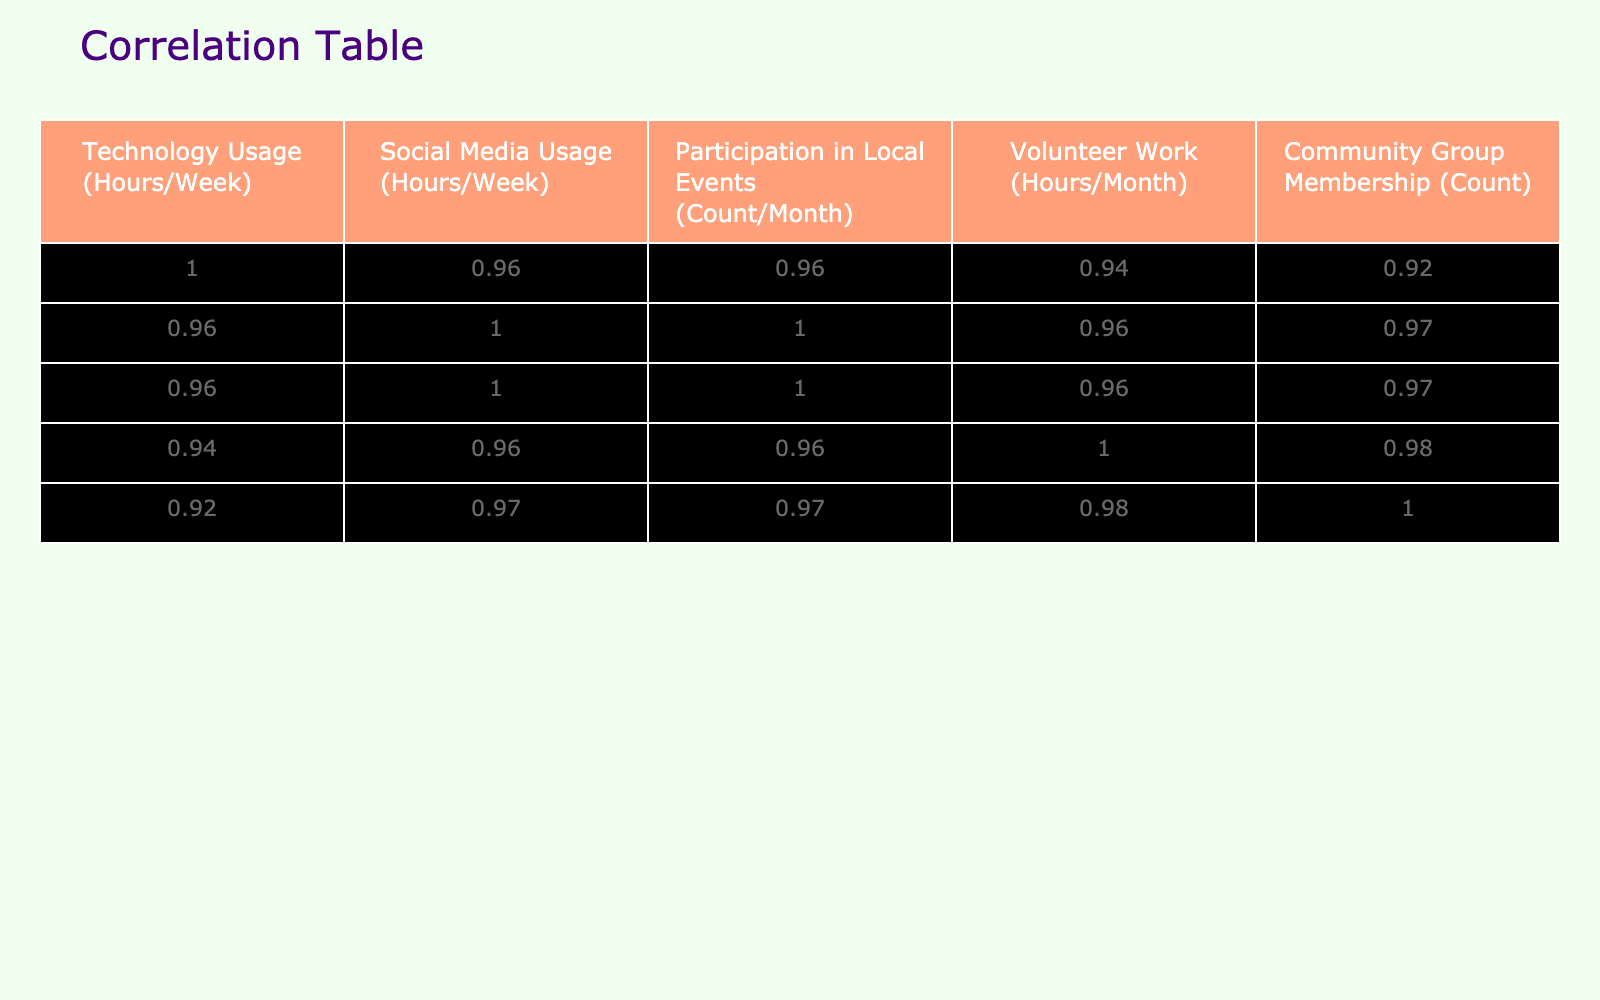What is the correlation between Technology Usage and Participation in Local Events? Looking at the correlation table, the value for the relationship between Technology Usage and Participation in Local Events is 0.82. This indicates a strong positive correlation, meaning that as technology usage increases, participation in local events also tends to increase.
Answer: 0.82 Is there a correlation between Volunteer Work and Community Group Membership? From the correlation table, the correlation coefficient for Volunteer Work and Community Group Membership is 0.71, which indicates a strong positive correlation between these two variables.
Answer: Yes What is the average amount of time spent on Social Media Usage for all participants? To find the average, we add all the values in the Social Media Usage column (2 + 3 + 1 + 4 + 3 + 2 + 1 + 5 + 0 + 6 = 27) and then divide by the number of participants (10). So, 27 divided by 10 equals 2.7.
Answer: 2.7 Which pair of variables has the highest correlation coefficient? The highest correlation coefficient in the table is between Technology Usage and Participation in Local Events, which is 0.82. This means that this pair has the strongest positive relationship among the variables.
Answer: Technology Usage and Participation in Local Events If an individual spends 10 hours per week on Technology Usage, what can be inferred about their Participation in Local Events? Given the strong positive correlation of 0.82, if an individual spends 10 hours on Technology Usage, we can infer that they are likely to participate in local events more frequently than those who use technology less. The exact participation cannot be determined but is expected to be higher based on the trend.
Answer: Likely higher participation Does increasing Technology Usage lead to a decrease in Volunteer Work hours? Referring to the correlation table, the correlation between Technology Usage and Volunteer Work is -0.19, indicating a very weak negative correlation. Therefore, it suggests that increasing technology usage does not necessarily lead to a decrease in Volunteer Work hours.
Answer: No What is the total participation in local events for all participants combined? To find the total participation, we sum the count of Participation in Local Events (3 + 4 + 2 + 5 + 4 + 3 + 2 + 6 + 1 + 7 = 37). Thus, the total participation for all participants is 37.
Answer: 37 What can be concluded about older residents who do not use technology at all? Older residents with zero technology usage (1 hour of usage: 0 participation) tend to have lower engagement in community services, as reflected by a correlation of 0.82, suggesting that technology connects them with events.
Answer: Lower engagement in community services 